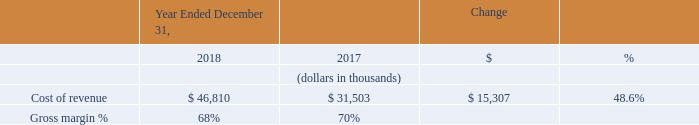Cost of Revenue
Cost of revenue increased by $15.3 million in 2018 compared to 2017. The increase was primarily due to a $7.2 million increase in employee-related costs, which includes stock-based compensation, associated with our increased headcount from 128 employees as of December 31, 2017 to 173 employees as of December 31, 2018. The remaining increase was principally the result of a $7.0 million increase in hosting, software and messaging costs, a $0.6 million increase attributed to office related expenses to support revenue generating activities and a $0.4 million increase in depreciation and amortization expense attributable to our acquired intangible assets.
Gross margin percentage decreased due to our continued investment in personnel and infrastructure to support our growth in revenue.
What was the increase in the cost of revenue in 2018? $15.3 million. What was the cost of revenue in 2018 and 2019?
Answer scale should be: thousand. 46,810, 31,503. What caused the decrease in gross margin percentage? Due to our continued investment in personnel and infrastructure to support our growth in revenue. What is the average cost of revenue for 2018 and 2019?
Answer scale should be: thousand. (46,810 + 31,503) / 2
Answer: 39156.5. In which year was cost of revenue less than 40,000 thousands? Locate and analyze cost of revenue in row 4
answer: 2017. What is the change in the gross margin between 2018 and 2019?
Answer scale should be: percent. 68 - 70
Answer: -2. 